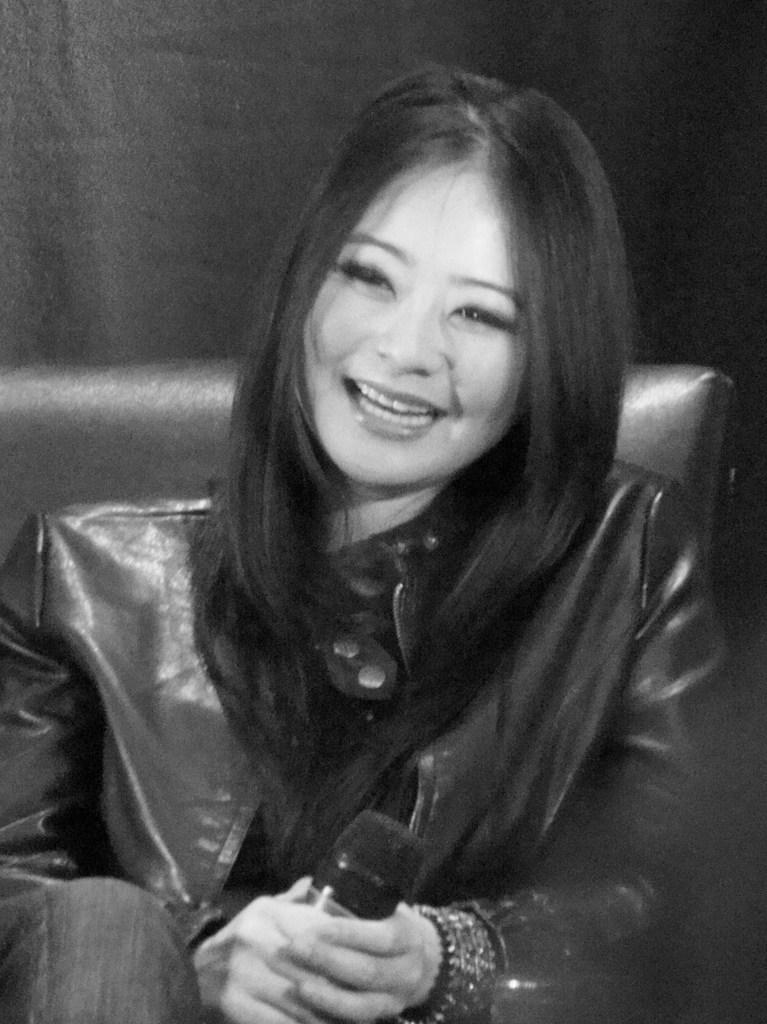Who is the main subject in the image? There is a woman in the image. What is the woman doing in the image? The woman is sitting on a chair and holding a microphone in her hand. What is the woman wearing in the image? The woman is wearing a jacket. How does the woman appear in the image? The woman is smiling in the image. What is the color scheme of the image? The image is in black and white color. Can you see any hens in the image? No, there are no hens present in the image. What type of cheese is the woman eating in the image? There is no cheese visible in the image; the woman is holding a microphone. 